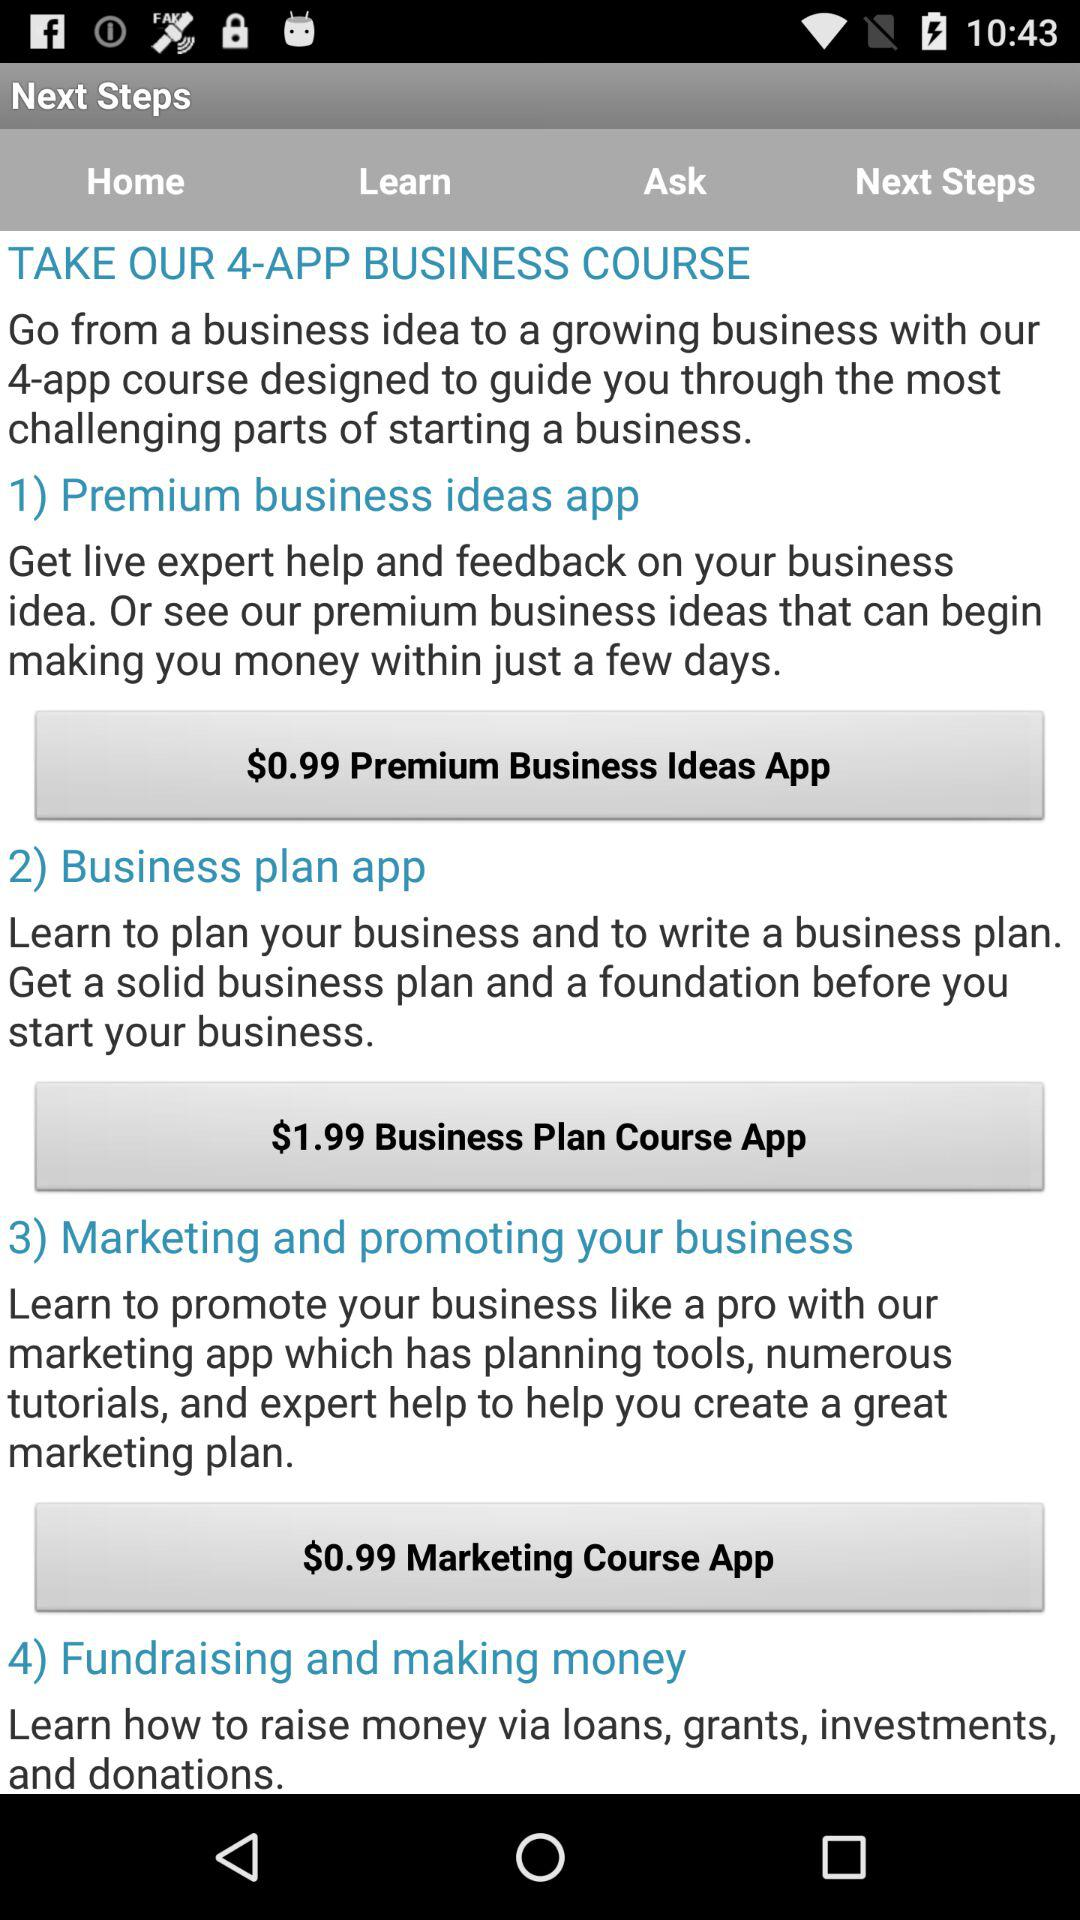How many apps are offered in the 4-app business course?
Answer the question using a single word or phrase. 4 